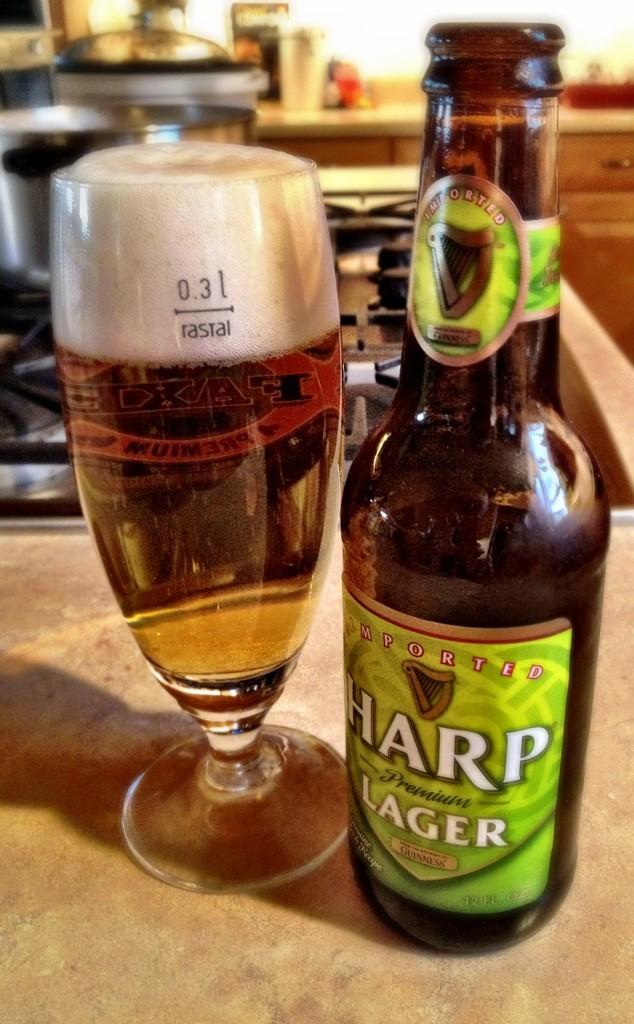<image>
Present a compact description of the photo's key features. A bottle of Harp lager next to a glass saying rastal 